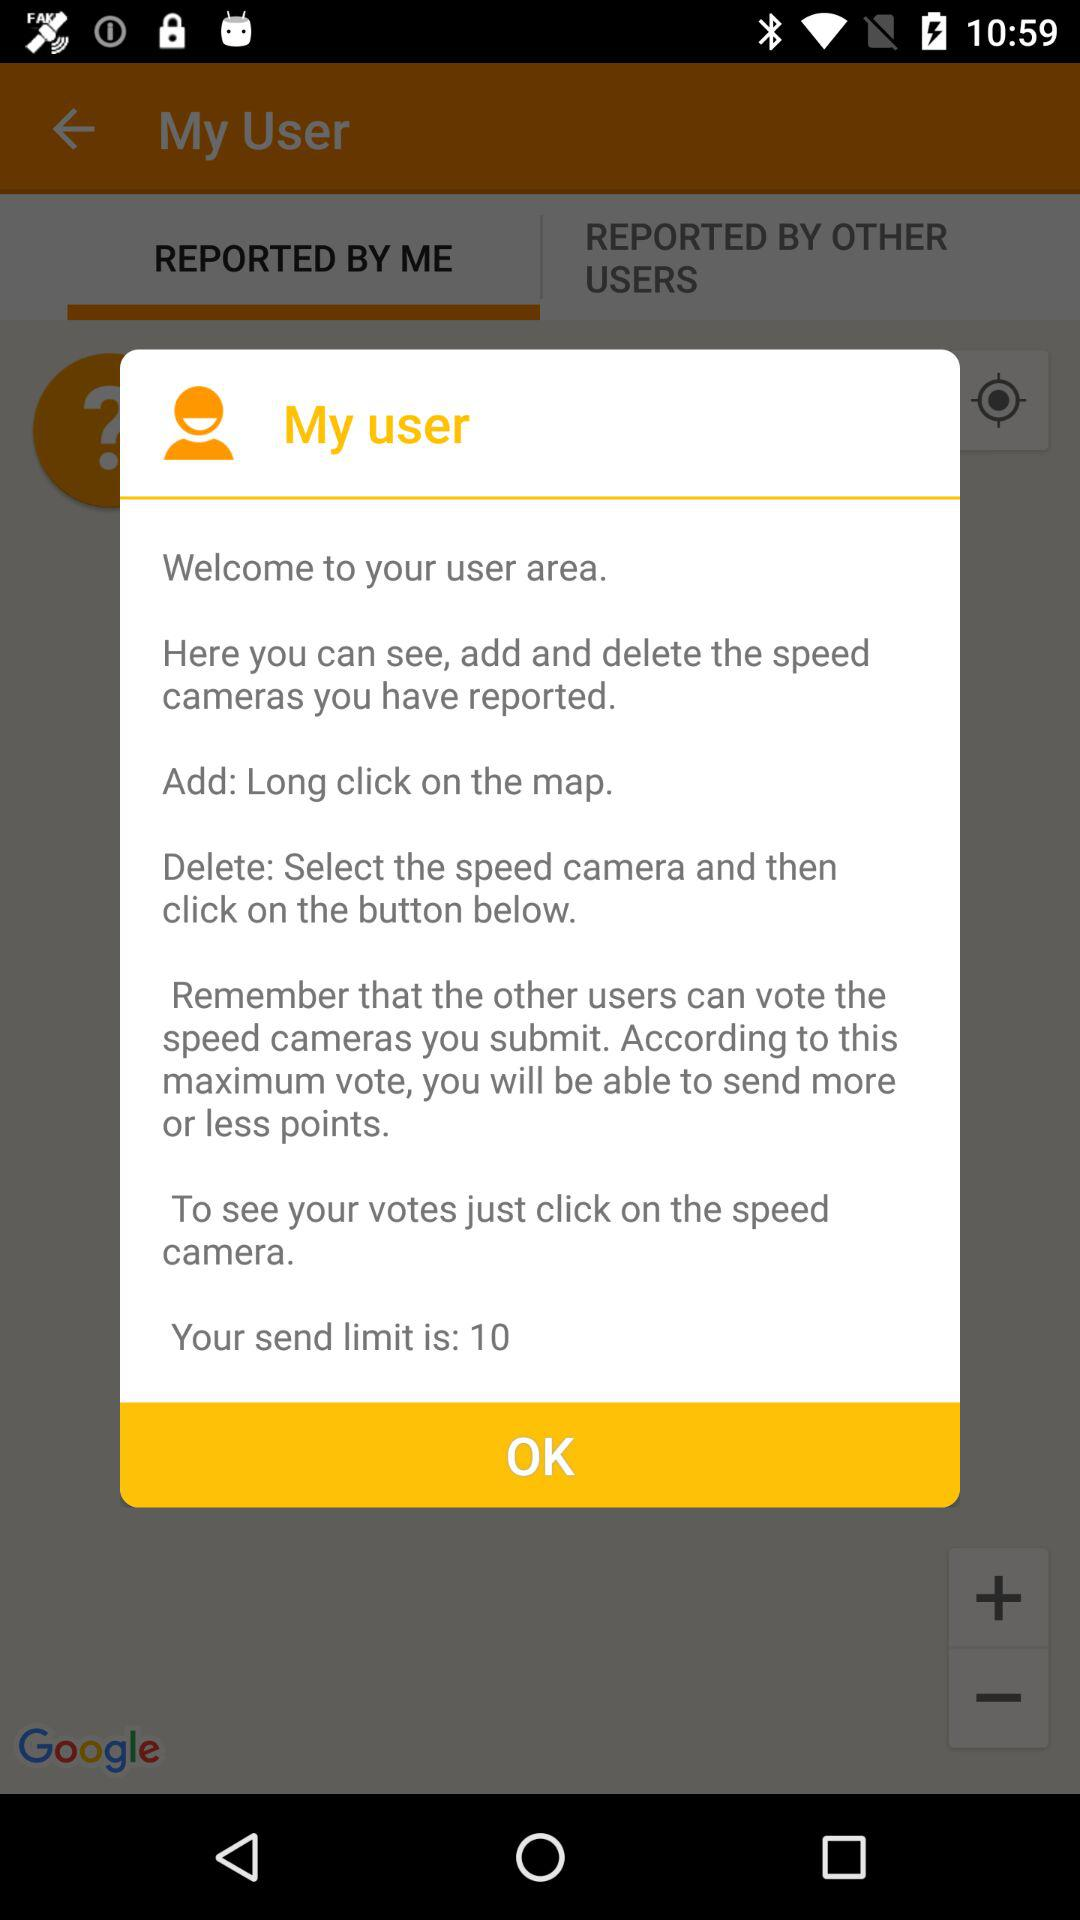What is the send limit? The send limit is 10. 